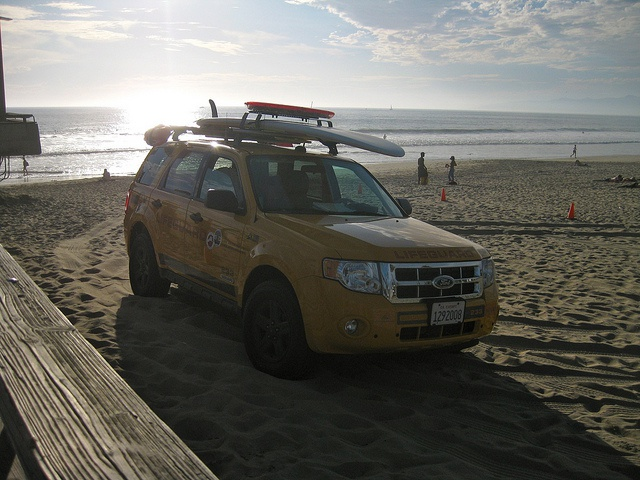Describe the objects in this image and their specific colors. I can see car in darkgray, black, and gray tones, surfboard in darkgray, gray, and black tones, people in darkgray, black, and gray tones, people in darkgray, black, and gray tones, and people in darkgray, black, and gray tones in this image. 